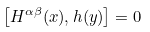<formula> <loc_0><loc_0><loc_500><loc_500>\left [ H ^ { \alpha \beta } ( x ) , h ( y ) \right ] = 0</formula> 